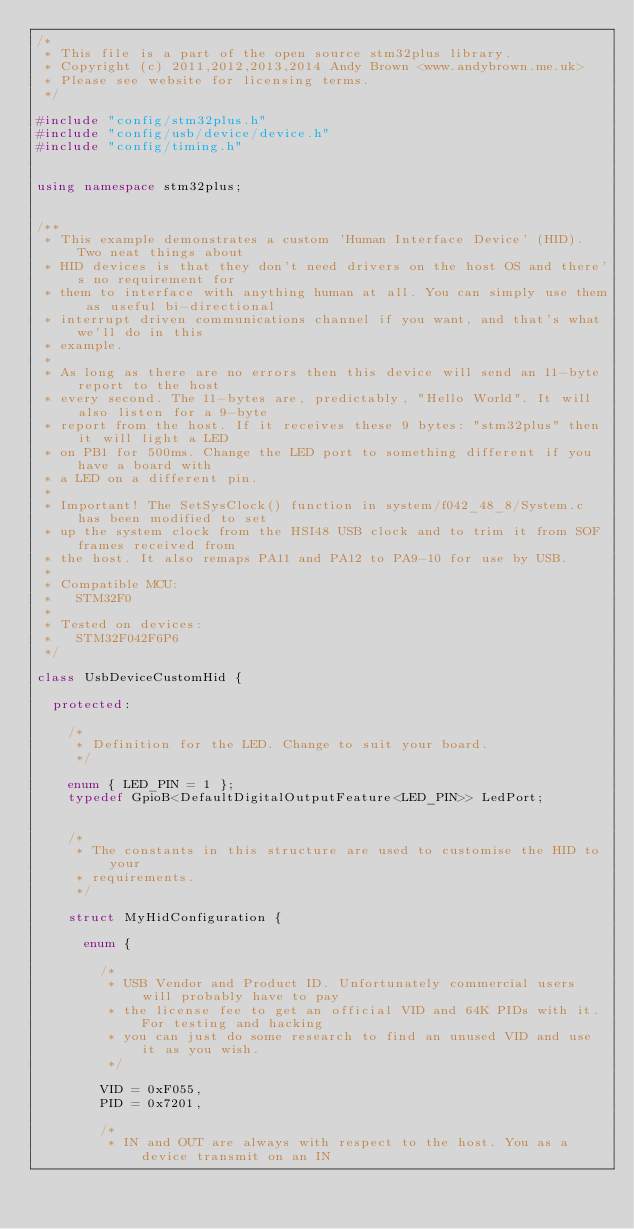Convert code to text. <code><loc_0><loc_0><loc_500><loc_500><_C++_>/*
 * This file is a part of the open source stm32plus library.
 * Copyright (c) 2011,2012,2013,2014 Andy Brown <www.andybrown.me.uk>
 * Please see website for licensing terms.
 */

#include "config/stm32plus.h"
#include "config/usb/device/device.h"
#include "config/timing.h"


using namespace stm32plus;


/**
 * This example demonstrates a custom 'Human Interface Device' (HID). Two neat things about
 * HID devices is that they don't need drivers on the host OS and there's no requirement for
 * them to interface with anything human at all. You can simply use them as useful bi-directional
 * interrupt driven communications channel if you want, and that's what we'll do in this
 * example.
 *
 * As long as there are no errors then this device will send an 11-byte report to the host
 * every second. The 11-bytes are, predictably, "Hello World". It will also listen for a 9-byte
 * report from the host. If it receives these 9 bytes: "stm32plus" then it will light a LED
 * on PB1 for 500ms. Change the LED port to something different if you have a board with
 * a LED on a different pin.
 *
 * Important! The SetSysClock() function in system/f042_48_8/System.c has been modified to set
 * up the system clock from the HSI48 USB clock and to trim it from SOF frames received from
 * the host. It also remaps PA11 and PA12 to PA9-10 for use by USB.
 *
 * Compatible MCU:
 *   STM32F0
 *
 * Tested on devices:
 *   STM32F042F6P6
 */

class UsbDeviceCustomHid {

  protected:

    /*
     * Definition for the LED. Change to suit your board.
     */

    enum { LED_PIN = 1 };
    typedef GpioB<DefaultDigitalOutputFeature<LED_PIN>> LedPort;


    /*
     * The constants in this structure are used to customise the HID to your
     * requirements.
     */

    struct MyHidConfiguration {

      enum {

        /*
         * USB Vendor and Product ID. Unfortunately commercial users will probably have to pay
         * the license fee to get an official VID and 64K PIDs with it. For testing and hacking
         * you can just do some research to find an unused VID and use it as you wish.
         */

        VID = 0xF055,
        PID = 0x7201,

        /*
         * IN and OUT are always with respect to the host. You as a device transmit on an IN</code> 